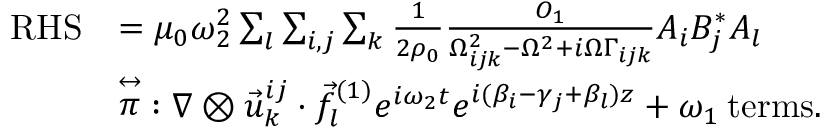<formula> <loc_0><loc_0><loc_500><loc_500>\begin{array} { r l } { R H S } & { = \mu _ { 0 } \omega _ { 2 } ^ { 2 } \sum _ { l } \sum _ { i , j } \sum _ { k } \frac { 1 } { 2 \rho _ { 0 } } \frac { O _ { 1 } } { \Omega _ { i j k } ^ { 2 } - \Omega ^ { 2 } + i \Omega \Gamma _ { i j k } } A _ { i } B _ { j } ^ { * } A _ { l } } \\ & { { \stackrel { \leftrightarrow } { \pi } } \colon \nabla \otimes \vec { u } _ { k } ^ { i j } \cdot \vec { f } _ { l } ^ { ( 1 ) } e ^ { i \omega _ { 2 } t } e ^ { i ( \beta _ { i } - \gamma _ { j } + \beta _ { l } ) z } + \omega _ { 1 } \, { t e r m s } . } \end{array}</formula> 